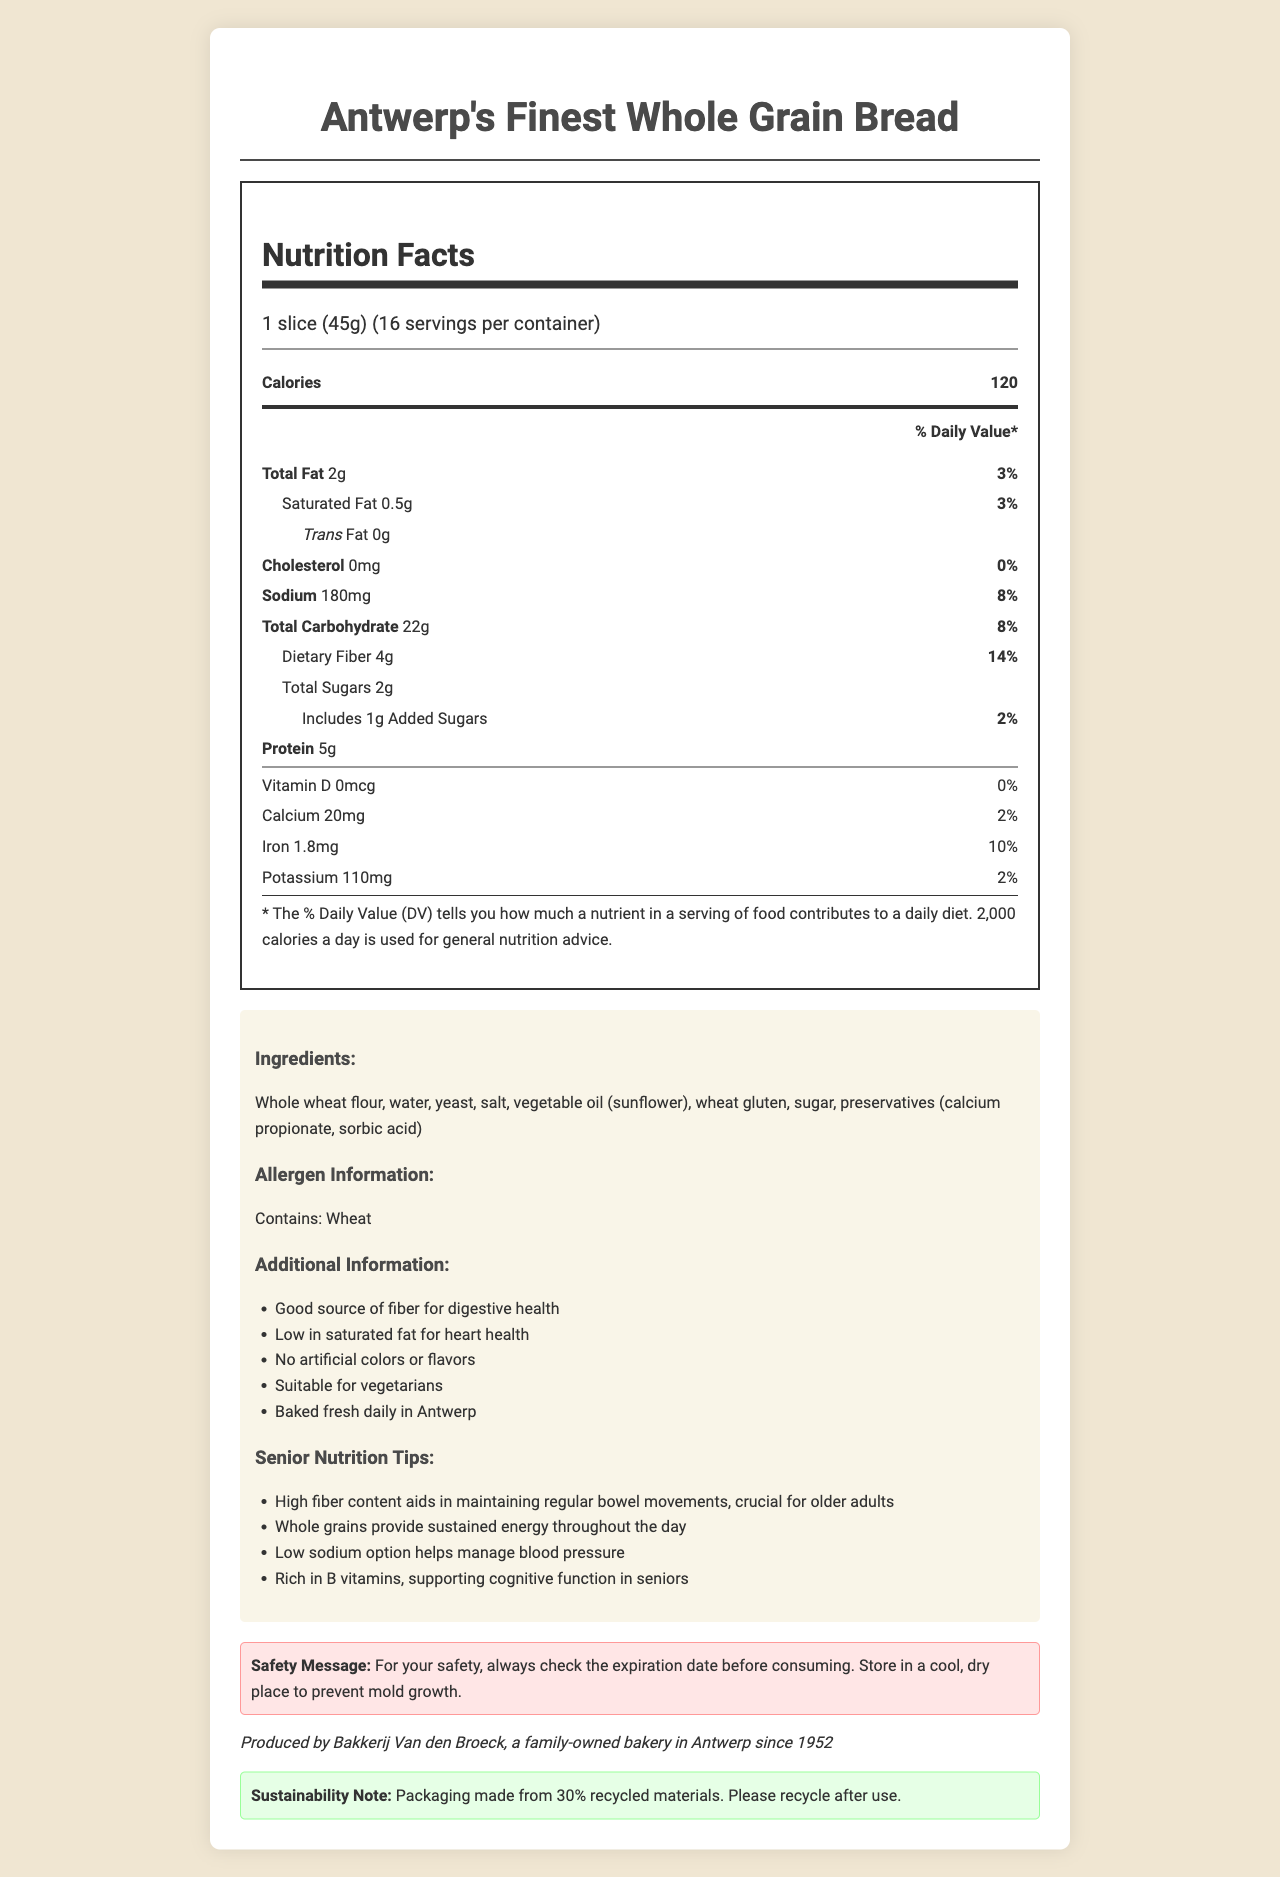what is the serving size for Antwerp's Finest Whole Grain Bread? The serving size information is provided at the beginning of the document in the serving information section.
Answer: 1 slice (45g) how many grams of dietary fiber are there per serving? The amount of dietary fiber per serving is listed under the "Total Carbohydrate" section in the nutrition facts.
Answer: 4g how many servings are there in one container? The information on servings per container is provided next to the serving size at the top of the nutrition facts label.
Answer: 16 what is the total amount of sodium per serving? The sodium content per serving is found in the main nutrition facts section.
Answer: 180mg what is the total number of calories per serving? The nutritional information listed shows that each serving contains 120 calories.
Answer: 120 which of the following ingredients is used as a preservative in the bread? A. Vitamin D B. Sorbic Acid C. Sunflower Oil D. Yeast The ingredients list includes Sorbic Acid as a preservative.
Answer: B. Sorbic Acid how much iron is in one serving as a percentage of the daily value? A. 2% B. 8% C. 10% D. 14% The percentage daily value of iron per serving is listed as 10% in the nutrition facts.
Answer: C. 10% does this product contain any trans fats? Under the nutrition facts, the document specifies that there are 0g of trans fats per serving.
Answer: No should this bread be stored in a warm, humid place? The safety message advises storing the bread in a cool, dry place to prevent mold growth.
Answer: No please summarize the main features and contents of this document. The concise summary highlights the key components of the document, including nutritional information, ingredients, allergen info, senior tips, safety instructions, local production, and sustainability features.
Answer: The document provides detailed nutrition facts for Antwerp's Finest Whole Grain Bread, including serving size, calories, and nutrient composition per serving. It highlights ingredients, allergen information, and additional nutritional benefits for seniors. There are important safety and storage instructions, a note on local production by an Antwerp-based bakery, and a brief on the sustainable packaging. who is the primary manufacturer of Antwerp's Finest Whole Grain Bread? The local connection section mentions that the bread is produced by Bakkerij Van den Broeck, a family-owned bakery in Antwerp since 1952.
Answer: Bakkerij Van den Broeck is the whole grain bread low in saturated fat? The document states in additional information that the bread is low in saturated fat.
Answer: Yes what are the B vitamin contents in the bread? The document does not provide specific information about B vitamin content.
Answer: Not enough information how many grams of sugar are added to this product per serving? The added sugars content per serving is specified under the "Total Sugars" section in the nutrition facts.
Answer: 1g is this bread suitable for vegetarians? The additional information section indicates that the bread is suitable for vegetarians.
Answer: Yes what is one health benefit of the high fiber content mentioned in senior nutrition tips? The senior nutrition tips mention that high fiber content helps maintain regular bowel movements, which is important for older adults.
Answer: Aids in maintaining regular bowel movements 